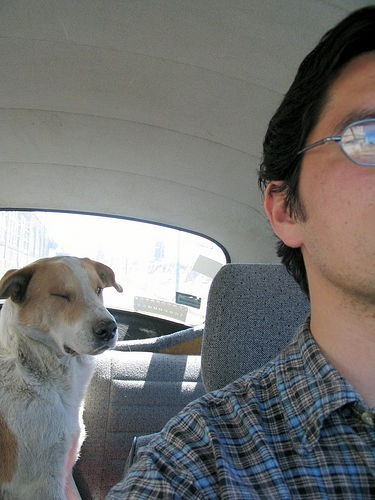Describe the objects in this image and their specific colors. I can see people in gray and black tones and dog in gray, darkgray, and black tones in this image. 